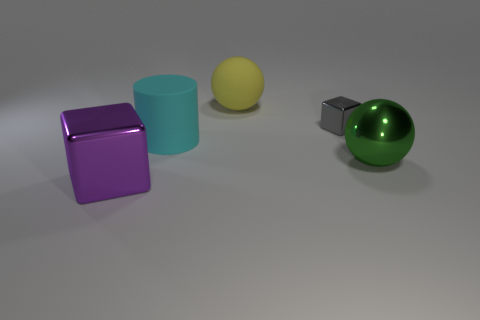Are there any other things that have the same shape as the green object?
Your response must be concise. Yes. Are there any other things that have the same size as the gray object?
Your answer should be compact. No. The other large object that is made of the same material as the green object is what color?
Your answer should be very brief. Purple. There is a big sphere right of the yellow sphere; what is its color?
Your answer should be compact. Green. How many big shiny cubes have the same color as the tiny shiny object?
Make the answer very short. 0. Is the number of balls that are to the right of the tiny gray metallic thing less than the number of cylinders that are in front of the purple object?
Your answer should be compact. No. How many big purple cubes are right of the gray metal block?
Keep it short and to the point. 0. Is there a cyan thing made of the same material as the large cylinder?
Your answer should be very brief. No. Is the number of small blocks that are in front of the small gray block greater than the number of large cyan objects that are in front of the cyan object?
Give a very brief answer. No. How big is the matte sphere?
Offer a very short reply. Large. 